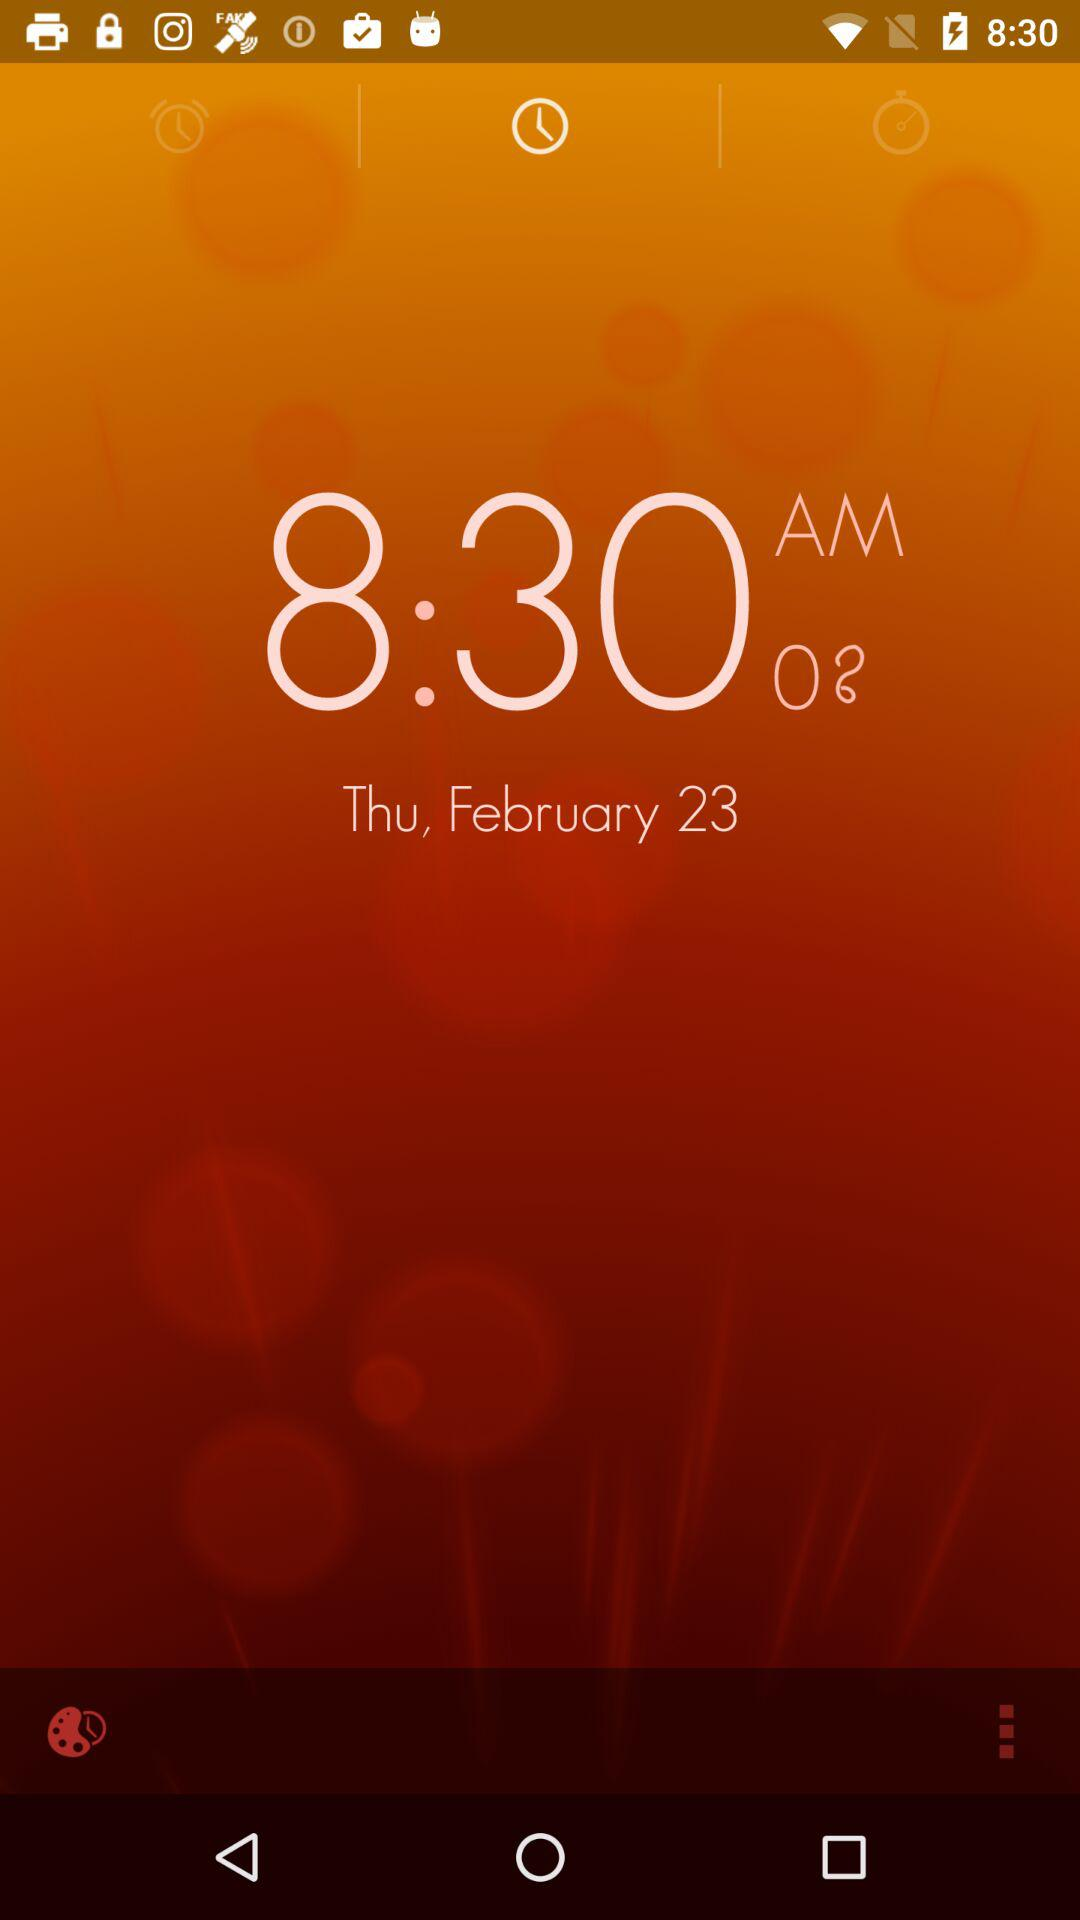What is the date today? The date is Thursday, February 23. 